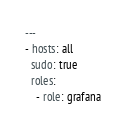Convert code to text. <code><loc_0><loc_0><loc_500><loc_500><_YAML_>---
- hosts: all
  sudo: true
  roles:
    - role: grafana
</code> 